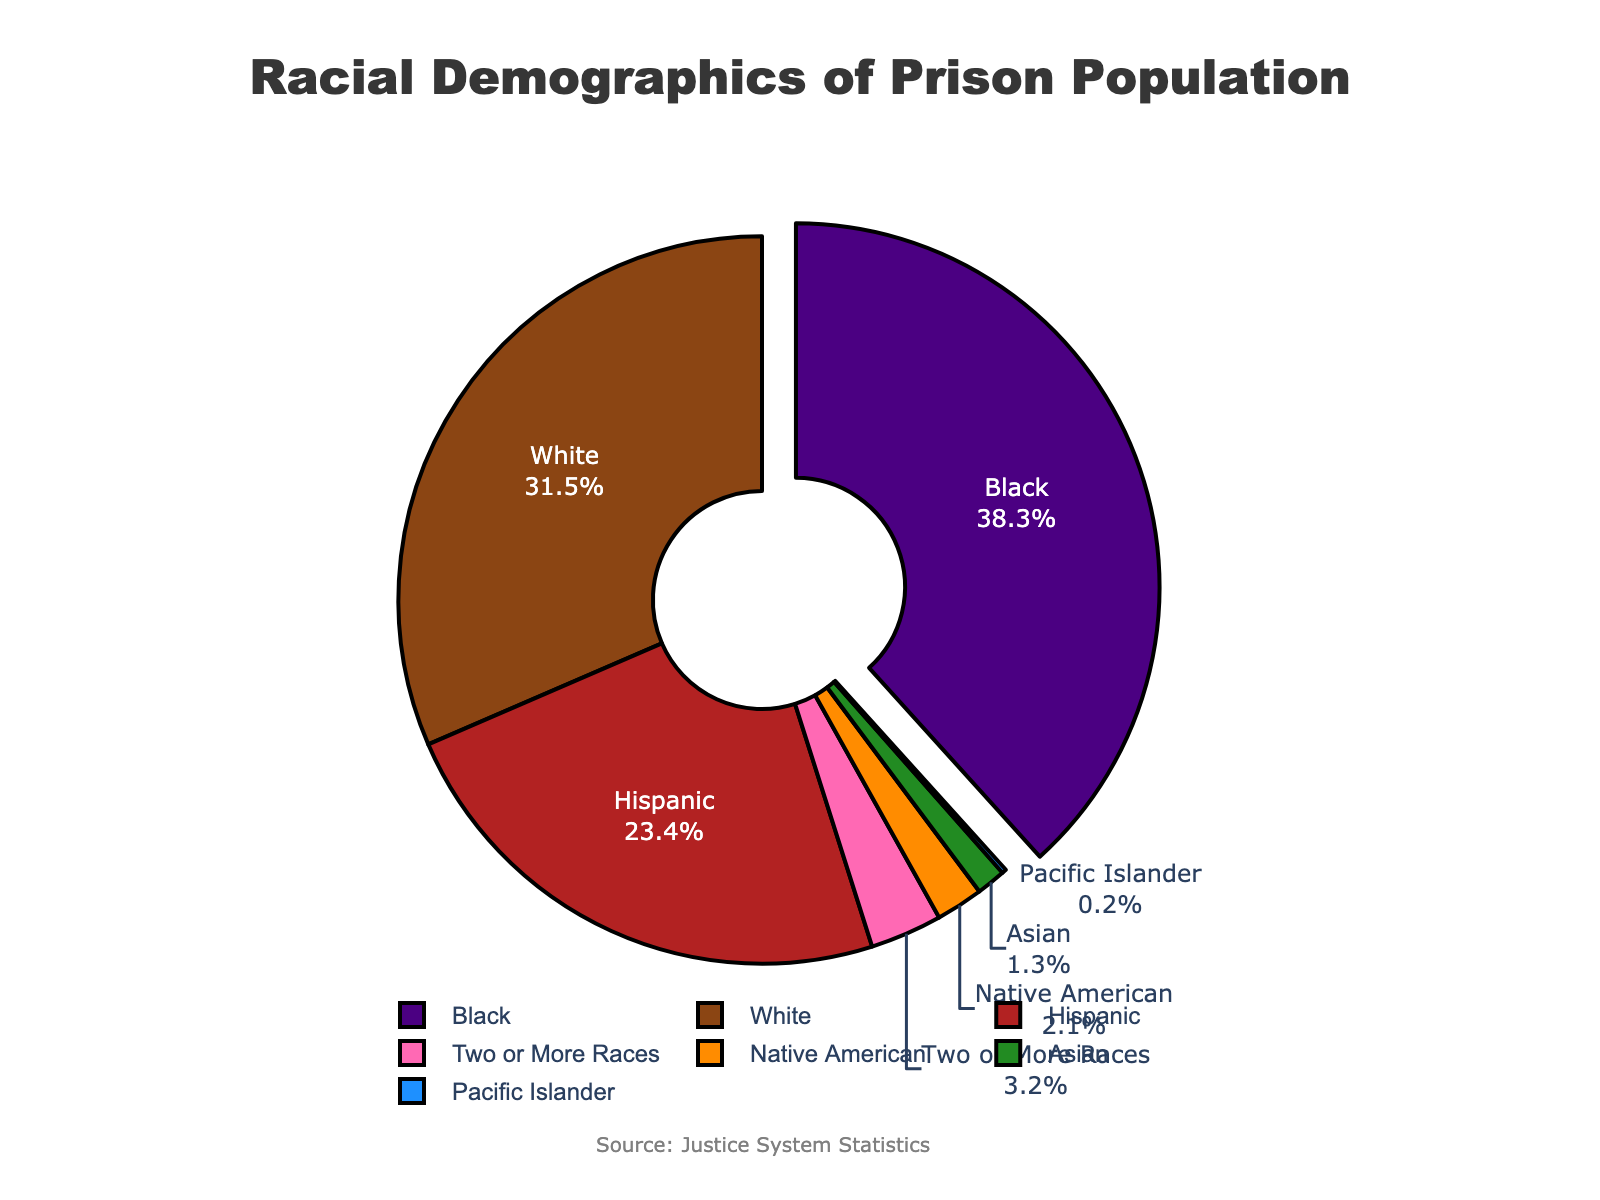Which racial demographic has the largest representation in the prison population? The largest percentage in the pie chart is highlighted by being pulled out from the rest. This segment represents 38.3% of the prison population, identifying it as the largest group.
Answer: Black What is the combined percentage of White and Hispanic prisoners in the population? The percentage of White prisoners is 31.5% and Hispanic prisoners is 23.4%. Adding these percentages gives 31.5 + 23.4 = 54.9%.
Answer: 54.9% Which racial demographic has the smallest representation in the prison population, and what is its percentage? The smallest segment in the pie chart is usually the least noticeable and carries the smallest percentage. Here, the smallest segment represents 0.2%.
Answer: Pacific Islander, 0.2% What is the difference in percentage between Black and White prisoners? The percentage of Black prisoners is 38.3% and White prisoners is 31.5%. The difference is calculated by subtracting 31.5 from 38.3, resulting in 38.3 - 31.5 = 6.8%.
Answer: 6.8% Which racial demographics make up less than 5% of the prison population each? By examining the chart, the racial demographics with percentages below 5% are visibly smaller segments. These segments include Asian (1.3%), Native American (2.1%), Pacific Islander (0.2%), and Two or More Races (3.2%).
Answer: Asian, Native American, Pacific Islander, Two or More Races What is the total percentage of the prison population that is composed of minority groups (non-White)? To find this, sum the percentages of all racial groups except White: 38.3 (Black) + 23.4 (Hispanic) + 1.3 (Asian) + 2.1 (Native American) + 0.2 (Pacific Islander) + 3.2 (Two or More Races) = 68.5%.
Answer: 68.5% How does the percentage of Hispanic prisoners compare to the percentage of Black prisoners? The percentage of Hispanic prisoners is 23.4%, while the percentage of Black prisoners is 38.3%. Therefore, the percentage of Hispanic prisoners is less than that of Black prisoners.
Answer: Less What visual indicator is used to emphasize the racial demographic with the largest population in the chart? The largest demographic (38.3% for Black) is pulled out from the rest of the pie chart, making it stand out visually.
Answer: It is pulled out Is the combined percentage of Asian, Native American, and Pacific Islander prisoners greater than 5%? The percentages for Asian, Native American, and Pacific Islander are 1.3%, 2.1%, and 0.2% respectively. Adding these up gives 1.3 + 2.1 + 0.2 = 3.6%.
Answer: No 